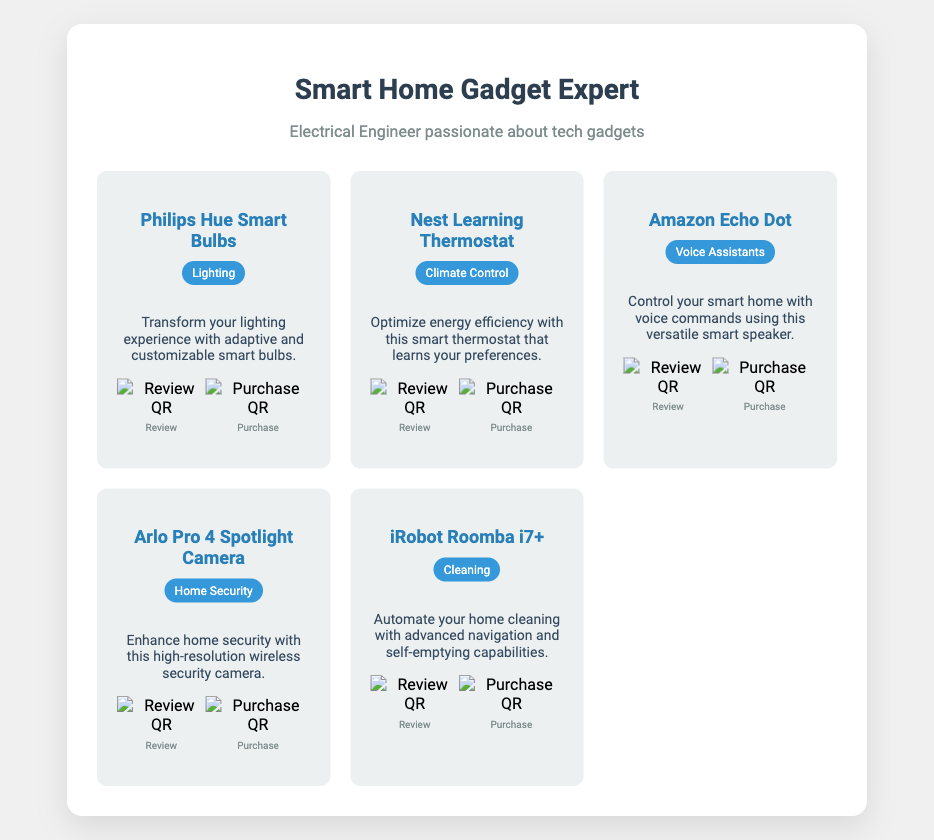what is the title of the document? The title of the document is displayed prominently at the top, which is "Smart Home Gadget Expert."
Answer: Smart Home Gadget Expert how many smart devices are listed? The number of smart devices can be counted in the document, which lists five devices.
Answer: 5 which device is categorized under "Lighting"? The device categorized under "Lighting" is identified by the specific title under that category in the document.
Answer: Philips Hue Smart Bulbs what feature does the Nest Learning Thermostat optimize? The feature that the Nest Learning Thermostat optimizes is mentioned explicitly in the document, relating to energy.
Answer: energy efficiency which device can automate home cleaning? The specific device that automates home cleaning is indicated in the description of the relevant device in the document.
Answer: iRobot Roomba i7+ what color is the category label for the Amazon Echo Dot? The color of the category label can be inferred from the style used in the document for that device.
Answer: blue how can the Arlo Pro 4 enhance security? The Arlo Pro 4's security enhancement is explained in the text, highlighting its capabilities.
Answer: high-resolution wireless security camera how many QR codes are available for each device? The number of QR codes for each device can be counted in the section regarding QR codes.
Answer: 2 